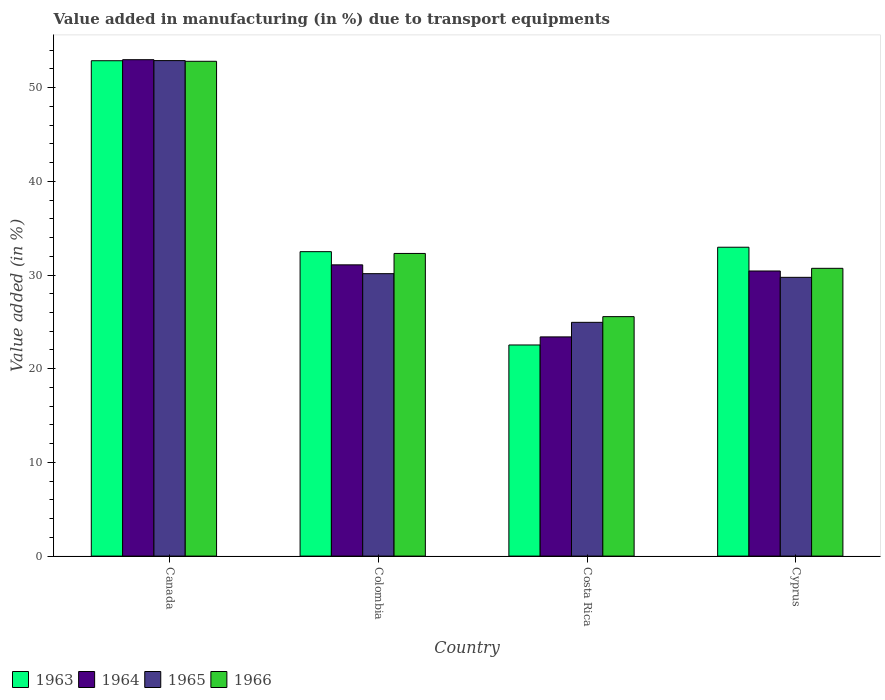How many different coloured bars are there?
Ensure brevity in your answer.  4. How many bars are there on the 2nd tick from the left?
Provide a succinct answer. 4. How many bars are there on the 4th tick from the right?
Your response must be concise. 4. What is the label of the 2nd group of bars from the left?
Provide a short and direct response. Colombia. In how many cases, is the number of bars for a given country not equal to the number of legend labels?
Your answer should be very brief. 0. What is the percentage of value added in manufacturing due to transport equipments in 1966 in Colombia?
Provide a succinct answer. 32.3. Across all countries, what is the maximum percentage of value added in manufacturing due to transport equipments in 1964?
Keep it short and to the point. 52.98. Across all countries, what is the minimum percentage of value added in manufacturing due to transport equipments in 1963?
Provide a succinct answer. 22.53. In which country was the percentage of value added in manufacturing due to transport equipments in 1963 maximum?
Make the answer very short. Canada. What is the total percentage of value added in manufacturing due to transport equipments in 1963 in the graph?
Give a very brief answer. 140.87. What is the difference between the percentage of value added in manufacturing due to transport equipments in 1966 in Colombia and that in Cyprus?
Offer a very short reply. 1.59. What is the difference between the percentage of value added in manufacturing due to transport equipments in 1963 in Cyprus and the percentage of value added in manufacturing due to transport equipments in 1965 in Canada?
Make the answer very short. -19.92. What is the average percentage of value added in manufacturing due to transport equipments in 1964 per country?
Provide a short and direct response. 34.47. What is the difference between the percentage of value added in manufacturing due to transport equipments of/in 1963 and percentage of value added in manufacturing due to transport equipments of/in 1966 in Cyprus?
Give a very brief answer. 2.25. What is the ratio of the percentage of value added in manufacturing due to transport equipments in 1963 in Colombia to that in Cyprus?
Your response must be concise. 0.99. Is the difference between the percentage of value added in manufacturing due to transport equipments in 1963 in Canada and Cyprus greater than the difference between the percentage of value added in manufacturing due to transport equipments in 1966 in Canada and Cyprus?
Your answer should be very brief. No. What is the difference between the highest and the second highest percentage of value added in manufacturing due to transport equipments in 1965?
Offer a very short reply. 23.13. What is the difference between the highest and the lowest percentage of value added in manufacturing due to transport equipments in 1966?
Keep it short and to the point. 27.25. Is the sum of the percentage of value added in manufacturing due to transport equipments in 1964 in Canada and Colombia greater than the maximum percentage of value added in manufacturing due to transport equipments in 1965 across all countries?
Offer a terse response. Yes. What does the 4th bar from the left in Colombia represents?
Provide a short and direct response. 1966. What does the 3rd bar from the right in Cyprus represents?
Your response must be concise. 1964. Is it the case that in every country, the sum of the percentage of value added in manufacturing due to transport equipments in 1966 and percentage of value added in manufacturing due to transport equipments in 1963 is greater than the percentage of value added in manufacturing due to transport equipments in 1965?
Provide a succinct answer. Yes. How many bars are there?
Provide a succinct answer. 16. Are all the bars in the graph horizontal?
Give a very brief answer. No. What is the difference between two consecutive major ticks on the Y-axis?
Your answer should be very brief. 10. Does the graph contain any zero values?
Provide a succinct answer. No. Does the graph contain grids?
Keep it short and to the point. No. Where does the legend appear in the graph?
Keep it short and to the point. Bottom left. How are the legend labels stacked?
Provide a short and direct response. Horizontal. What is the title of the graph?
Your answer should be very brief. Value added in manufacturing (in %) due to transport equipments. Does "1965" appear as one of the legend labels in the graph?
Provide a short and direct response. Yes. What is the label or title of the X-axis?
Give a very brief answer. Country. What is the label or title of the Y-axis?
Provide a succinct answer. Value added (in %). What is the Value added (in %) in 1963 in Canada?
Provide a short and direct response. 52.87. What is the Value added (in %) of 1964 in Canada?
Give a very brief answer. 52.98. What is the Value added (in %) of 1965 in Canada?
Provide a succinct answer. 52.89. What is the Value added (in %) in 1966 in Canada?
Keep it short and to the point. 52.81. What is the Value added (in %) in 1963 in Colombia?
Give a very brief answer. 32.49. What is the Value added (in %) in 1964 in Colombia?
Provide a short and direct response. 31.09. What is the Value added (in %) of 1965 in Colombia?
Your response must be concise. 30.15. What is the Value added (in %) in 1966 in Colombia?
Provide a short and direct response. 32.3. What is the Value added (in %) in 1963 in Costa Rica?
Make the answer very short. 22.53. What is the Value added (in %) in 1964 in Costa Rica?
Your answer should be compact. 23.4. What is the Value added (in %) in 1965 in Costa Rica?
Your response must be concise. 24.95. What is the Value added (in %) in 1966 in Costa Rica?
Ensure brevity in your answer.  25.56. What is the Value added (in %) of 1963 in Cyprus?
Make the answer very short. 32.97. What is the Value added (in %) in 1964 in Cyprus?
Offer a very short reply. 30.43. What is the Value added (in %) in 1965 in Cyprus?
Provide a succinct answer. 29.75. What is the Value added (in %) of 1966 in Cyprus?
Offer a very short reply. 30.72. Across all countries, what is the maximum Value added (in %) in 1963?
Your answer should be very brief. 52.87. Across all countries, what is the maximum Value added (in %) in 1964?
Provide a short and direct response. 52.98. Across all countries, what is the maximum Value added (in %) in 1965?
Your answer should be very brief. 52.89. Across all countries, what is the maximum Value added (in %) in 1966?
Your answer should be very brief. 52.81. Across all countries, what is the minimum Value added (in %) in 1963?
Keep it short and to the point. 22.53. Across all countries, what is the minimum Value added (in %) in 1964?
Ensure brevity in your answer.  23.4. Across all countries, what is the minimum Value added (in %) in 1965?
Give a very brief answer. 24.95. Across all countries, what is the minimum Value added (in %) of 1966?
Provide a short and direct response. 25.56. What is the total Value added (in %) of 1963 in the graph?
Your answer should be very brief. 140.87. What is the total Value added (in %) in 1964 in the graph?
Your answer should be compact. 137.89. What is the total Value added (in %) in 1965 in the graph?
Your response must be concise. 137.73. What is the total Value added (in %) in 1966 in the graph?
Offer a terse response. 141.39. What is the difference between the Value added (in %) in 1963 in Canada and that in Colombia?
Keep it short and to the point. 20.38. What is the difference between the Value added (in %) of 1964 in Canada and that in Colombia?
Provide a short and direct response. 21.9. What is the difference between the Value added (in %) in 1965 in Canada and that in Colombia?
Provide a short and direct response. 22.74. What is the difference between the Value added (in %) in 1966 in Canada and that in Colombia?
Your answer should be very brief. 20.51. What is the difference between the Value added (in %) in 1963 in Canada and that in Costa Rica?
Offer a terse response. 30.34. What is the difference between the Value added (in %) of 1964 in Canada and that in Costa Rica?
Ensure brevity in your answer.  29.59. What is the difference between the Value added (in %) in 1965 in Canada and that in Costa Rica?
Your answer should be compact. 27.93. What is the difference between the Value added (in %) of 1966 in Canada and that in Costa Rica?
Offer a very short reply. 27.25. What is the difference between the Value added (in %) in 1963 in Canada and that in Cyprus?
Provide a succinct answer. 19.91. What is the difference between the Value added (in %) of 1964 in Canada and that in Cyprus?
Provide a short and direct response. 22.55. What is the difference between the Value added (in %) in 1965 in Canada and that in Cyprus?
Provide a succinct answer. 23.13. What is the difference between the Value added (in %) of 1966 in Canada and that in Cyprus?
Your answer should be compact. 22.1. What is the difference between the Value added (in %) in 1963 in Colombia and that in Costa Rica?
Offer a terse response. 9.96. What is the difference between the Value added (in %) of 1964 in Colombia and that in Costa Rica?
Give a very brief answer. 7.69. What is the difference between the Value added (in %) in 1965 in Colombia and that in Costa Rica?
Offer a terse response. 5.2. What is the difference between the Value added (in %) in 1966 in Colombia and that in Costa Rica?
Your answer should be compact. 6.74. What is the difference between the Value added (in %) in 1963 in Colombia and that in Cyprus?
Provide a succinct answer. -0.47. What is the difference between the Value added (in %) of 1964 in Colombia and that in Cyprus?
Offer a very short reply. 0.66. What is the difference between the Value added (in %) in 1965 in Colombia and that in Cyprus?
Keep it short and to the point. 0.39. What is the difference between the Value added (in %) of 1966 in Colombia and that in Cyprus?
Offer a terse response. 1.59. What is the difference between the Value added (in %) of 1963 in Costa Rica and that in Cyprus?
Provide a short and direct response. -10.43. What is the difference between the Value added (in %) in 1964 in Costa Rica and that in Cyprus?
Your answer should be very brief. -7.03. What is the difference between the Value added (in %) of 1965 in Costa Rica and that in Cyprus?
Offer a very short reply. -4.8. What is the difference between the Value added (in %) of 1966 in Costa Rica and that in Cyprus?
Your answer should be very brief. -5.16. What is the difference between the Value added (in %) in 1963 in Canada and the Value added (in %) in 1964 in Colombia?
Give a very brief answer. 21.79. What is the difference between the Value added (in %) in 1963 in Canada and the Value added (in %) in 1965 in Colombia?
Provide a succinct answer. 22.73. What is the difference between the Value added (in %) in 1963 in Canada and the Value added (in %) in 1966 in Colombia?
Make the answer very short. 20.57. What is the difference between the Value added (in %) of 1964 in Canada and the Value added (in %) of 1965 in Colombia?
Make the answer very short. 22.84. What is the difference between the Value added (in %) in 1964 in Canada and the Value added (in %) in 1966 in Colombia?
Make the answer very short. 20.68. What is the difference between the Value added (in %) in 1965 in Canada and the Value added (in %) in 1966 in Colombia?
Provide a short and direct response. 20.58. What is the difference between the Value added (in %) of 1963 in Canada and the Value added (in %) of 1964 in Costa Rica?
Your answer should be compact. 29.48. What is the difference between the Value added (in %) in 1963 in Canada and the Value added (in %) in 1965 in Costa Rica?
Keep it short and to the point. 27.92. What is the difference between the Value added (in %) of 1963 in Canada and the Value added (in %) of 1966 in Costa Rica?
Your answer should be compact. 27.31. What is the difference between the Value added (in %) of 1964 in Canada and the Value added (in %) of 1965 in Costa Rica?
Keep it short and to the point. 28.03. What is the difference between the Value added (in %) of 1964 in Canada and the Value added (in %) of 1966 in Costa Rica?
Provide a succinct answer. 27.42. What is the difference between the Value added (in %) in 1965 in Canada and the Value added (in %) in 1966 in Costa Rica?
Provide a succinct answer. 27.33. What is the difference between the Value added (in %) of 1963 in Canada and the Value added (in %) of 1964 in Cyprus?
Make the answer very short. 22.44. What is the difference between the Value added (in %) of 1963 in Canada and the Value added (in %) of 1965 in Cyprus?
Ensure brevity in your answer.  23.12. What is the difference between the Value added (in %) in 1963 in Canada and the Value added (in %) in 1966 in Cyprus?
Give a very brief answer. 22.16. What is the difference between the Value added (in %) in 1964 in Canada and the Value added (in %) in 1965 in Cyprus?
Your answer should be compact. 23.23. What is the difference between the Value added (in %) of 1964 in Canada and the Value added (in %) of 1966 in Cyprus?
Ensure brevity in your answer.  22.27. What is the difference between the Value added (in %) of 1965 in Canada and the Value added (in %) of 1966 in Cyprus?
Provide a succinct answer. 22.17. What is the difference between the Value added (in %) in 1963 in Colombia and the Value added (in %) in 1964 in Costa Rica?
Provide a short and direct response. 9.1. What is the difference between the Value added (in %) in 1963 in Colombia and the Value added (in %) in 1965 in Costa Rica?
Your response must be concise. 7.54. What is the difference between the Value added (in %) of 1963 in Colombia and the Value added (in %) of 1966 in Costa Rica?
Make the answer very short. 6.93. What is the difference between the Value added (in %) of 1964 in Colombia and the Value added (in %) of 1965 in Costa Rica?
Your answer should be compact. 6.14. What is the difference between the Value added (in %) of 1964 in Colombia and the Value added (in %) of 1966 in Costa Rica?
Make the answer very short. 5.53. What is the difference between the Value added (in %) in 1965 in Colombia and the Value added (in %) in 1966 in Costa Rica?
Your answer should be very brief. 4.59. What is the difference between the Value added (in %) of 1963 in Colombia and the Value added (in %) of 1964 in Cyprus?
Your answer should be very brief. 2.06. What is the difference between the Value added (in %) in 1963 in Colombia and the Value added (in %) in 1965 in Cyprus?
Make the answer very short. 2.74. What is the difference between the Value added (in %) of 1963 in Colombia and the Value added (in %) of 1966 in Cyprus?
Offer a very short reply. 1.78. What is the difference between the Value added (in %) of 1964 in Colombia and the Value added (in %) of 1965 in Cyprus?
Offer a very short reply. 1.33. What is the difference between the Value added (in %) in 1964 in Colombia and the Value added (in %) in 1966 in Cyprus?
Your answer should be very brief. 0.37. What is the difference between the Value added (in %) of 1965 in Colombia and the Value added (in %) of 1966 in Cyprus?
Keep it short and to the point. -0.57. What is the difference between the Value added (in %) in 1963 in Costa Rica and the Value added (in %) in 1964 in Cyprus?
Your answer should be very brief. -7.9. What is the difference between the Value added (in %) in 1963 in Costa Rica and the Value added (in %) in 1965 in Cyprus?
Keep it short and to the point. -7.22. What is the difference between the Value added (in %) of 1963 in Costa Rica and the Value added (in %) of 1966 in Cyprus?
Make the answer very short. -8.18. What is the difference between the Value added (in %) of 1964 in Costa Rica and the Value added (in %) of 1965 in Cyprus?
Make the answer very short. -6.36. What is the difference between the Value added (in %) in 1964 in Costa Rica and the Value added (in %) in 1966 in Cyprus?
Keep it short and to the point. -7.32. What is the difference between the Value added (in %) in 1965 in Costa Rica and the Value added (in %) in 1966 in Cyprus?
Your answer should be very brief. -5.77. What is the average Value added (in %) in 1963 per country?
Your answer should be very brief. 35.22. What is the average Value added (in %) in 1964 per country?
Ensure brevity in your answer.  34.47. What is the average Value added (in %) of 1965 per country?
Keep it short and to the point. 34.43. What is the average Value added (in %) of 1966 per country?
Your answer should be compact. 35.35. What is the difference between the Value added (in %) in 1963 and Value added (in %) in 1964 in Canada?
Offer a very short reply. -0.11. What is the difference between the Value added (in %) of 1963 and Value added (in %) of 1965 in Canada?
Your answer should be very brief. -0.01. What is the difference between the Value added (in %) in 1963 and Value added (in %) in 1966 in Canada?
Give a very brief answer. 0.06. What is the difference between the Value added (in %) in 1964 and Value added (in %) in 1965 in Canada?
Give a very brief answer. 0.1. What is the difference between the Value added (in %) of 1964 and Value added (in %) of 1966 in Canada?
Ensure brevity in your answer.  0.17. What is the difference between the Value added (in %) in 1965 and Value added (in %) in 1966 in Canada?
Make the answer very short. 0.07. What is the difference between the Value added (in %) in 1963 and Value added (in %) in 1964 in Colombia?
Provide a short and direct response. 1.41. What is the difference between the Value added (in %) of 1963 and Value added (in %) of 1965 in Colombia?
Ensure brevity in your answer.  2.35. What is the difference between the Value added (in %) of 1963 and Value added (in %) of 1966 in Colombia?
Provide a succinct answer. 0.19. What is the difference between the Value added (in %) in 1964 and Value added (in %) in 1965 in Colombia?
Keep it short and to the point. 0.94. What is the difference between the Value added (in %) of 1964 and Value added (in %) of 1966 in Colombia?
Offer a very short reply. -1.22. What is the difference between the Value added (in %) of 1965 and Value added (in %) of 1966 in Colombia?
Ensure brevity in your answer.  -2.16. What is the difference between the Value added (in %) of 1963 and Value added (in %) of 1964 in Costa Rica?
Your response must be concise. -0.86. What is the difference between the Value added (in %) in 1963 and Value added (in %) in 1965 in Costa Rica?
Keep it short and to the point. -2.42. What is the difference between the Value added (in %) of 1963 and Value added (in %) of 1966 in Costa Rica?
Ensure brevity in your answer.  -3.03. What is the difference between the Value added (in %) of 1964 and Value added (in %) of 1965 in Costa Rica?
Give a very brief answer. -1.55. What is the difference between the Value added (in %) in 1964 and Value added (in %) in 1966 in Costa Rica?
Give a very brief answer. -2.16. What is the difference between the Value added (in %) in 1965 and Value added (in %) in 1966 in Costa Rica?
Provide a succinct answer. -0.61. What is the difference between the Value added (in %) in 1963 and Value added (in %) in 1964 in Cyprus?
Your answer should be compact. 2.54. What is the difference between the Value added (in %) in 1963 and Value added (in %) in 1965 in Cyprus?
Provide a short and direct response. 3.21. What is the difference between the Value added (in %) in 1963 and Value added (in %) in 1966 in Cyprus?
Ensure brevity in your answer.  2.25. What is the difference between the Value added (in %) of 1964 and Value added (in %) of 1965 in Cyprus?
Ensure brevity in your answer.  0.68. What is the difference between the Value added (in %) of 1964 and Value added (in %) of 1966 in Cyprus?
Your answer should be compact. -0.29. What is the difference between the Value added (in %) of 1965 and Value added (in %) of 1966 in Cyprus?
Ensure brevity in your answer.  -0.96. What is the ratio of the Value added (in %) in 1963 in Canada to that in Colombia?
Ensure brevity in your answer.  1.63. What is the ratio of the Value added (in %) in 1964 in Canada to that in Colombia?
Offer a terse response. 1.7. What is the ratio of the Value added (in %) of 1965 in Canada to that in Colombia?
Your answer should be compact. 1.75. What is the ratio of the Value added (in %) of 1966 in Canada to that in Colombia?
Provide a short and direct response. 1.63. What is the ratio of the Value added (in %) in 1963 in Canada to that in Costa Rica?
Your answer should be very brief. 2.35. What is the ratio of the Value added (in %) of 1964 in Canada to that in Costa Rica?
Provide a short and direct response. 2.26. What is the ratio of the Value added (in %) in 1965 in Canada to that in Costa Rica?
Your answer should be very brief. 2.12. What is the ratio of the Value added (in %) of 1966 in Canada to that in Costa Rica?
Provide a short and direct response. 2.07. What is the ratio of the Value added (in %) in 1963 in Canada to that in Cyprus?
Your answer should be very brief. 1.6. What is the ratio of the Value added (in %) in 1964 in Canada to that in Cyprus?
Give a very brief answer. 1.74. What is the ratio of the Value added (in %) in 1965 in Canada to that in Cyprus?
Provide a short and direct response. 1.78. What is the ratio of the Value added (in %) of 1966 in Canada to that in Cyprus?
Provide a short and direct response. 1.72. What is the ratio of the Value added (in %) in 1963 in Colombia to that in Costa Rica?
Offer a very short reply. 1.44. What is the ratio of the Value added (in %) of 1964 in Colombia to that in Costa Rica?
Provide a short and direct response. 1.33. What is the ratio of the Value added (in %) in 1965 in Colombia to that in Costa Rica?
Ensure brevity in your answer.  1.21. What is the ratio of the Value added (in %) in 1966 in Colombia to that in Costa Rica?
Provide a short and direct response. 1.26. What is the ratio of the Value added (in %) of 1963 in Colombia to that in Cyprus?
Offer a terse response. 0.99. What is the ratio of the Value added (in %) of 1964 in Colombia to that in Cyprus?
Offer a terse response. 1.02. What is the ratio of the Value added (in %) of 1965 in Colombia to that in Cyprus?
Make the answer very short. 1.01. What is the ratio of the Value added (in %) of 1966 in Colombia to that in Cyprus?
Provide a short and direct response. 1.05. What is the ratio of the Value added (in %) of 1963 in Costa Rica to that in Cyprus?
Ensure brevity in your answer.  0.68. What is the ratio of the Value added (in %) of 1964 in Costa Rica to that in Cyprus?
Give a very brief answer. 0.77. What is the ratio of the Value added (in %) of 1965 in Costa Rica to that in Cyprus?
Provide a succinct answer. 0.84. What is the ratio of the Value added (in %) in 1966 in Costa Rica to that in Cyprus?
Offer a terse response. 0.83. What is the difference between the highest and the second highest Value added (in %) of 1963?
Provide a short and direct response. 19.91. What is the difference between the highest and the second highest Value added (in %) of 1964?
Provide a succinct answer. 21.9. What is the difference between the highest and the second highest Value added (in %) in 1965?
Make the answer very short. 22.74. What is the difference between the highest and the second highest Value added (in %) in 1966?
Your answer should be compact. 20.51. What is the difference between the highest and the lowest Value added (in %) of 1963?
Provide a short and direct response. 30.34. What is the difference between the highest and the lowest Value added (in %) in 1964?
Your answer should be compact. 29.59. What is the difference between the highest and the lowest Value added (in %) of 1965?
Ensure brevity in your answer.  27.93. What is the difference between the highest and the lowest Value added (in %) of 1966?
Your response must be concise. 27.25. 